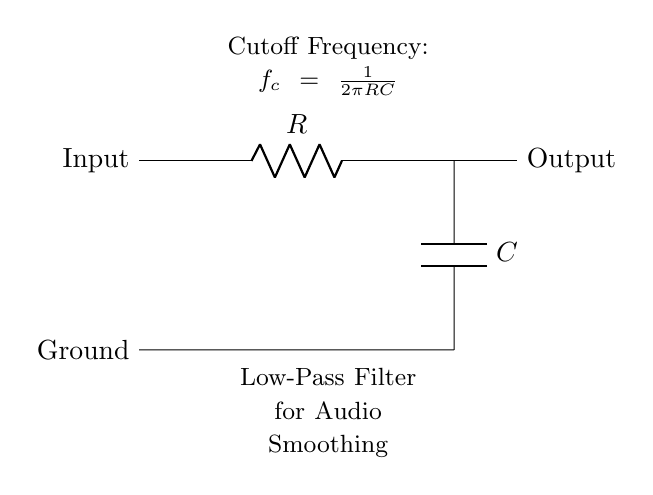What components are used in the circuit? The circuit utilizes a resistor and a capacitor, which are typical components in a low-pass filter. The diagram labels these components as R and C, respectively.
Answer: Resistor and Capacitor What is the function of the low-pass filter? The low-pass filter allows low-frequency signals to pass while attenuating high-frequency signals. This helps in smoothing audio signals, removing noise for better sound quality in animations.
Answer: Smoothing audio signals What is the output of the circuit? The output is taken from the right side of the capacitor, and it represents the smoothed audio signal after filtering.
Answer: Smoothed audio signal What happens to high-frequency signals in this circuit? High-frequency signals are attenuated, meaning their amplitude is reduced significantly, resulting in a cleaner audio output.
Answer: Attenuated How is the cutoff frequency determined? The cutoff frequency is given by the formula f_c = 1/(2πRC). By adjusting R and C values, the designer can set the frequency at which signals start to be filtered out.
Answer: 1/(2πRC) What does the term "ground" refer to in this circuit? Ground serves as a reference point for voltage and is typically at zero volts. It is essential for completing the circuit and ensuring proper operation of the components.
Answer: Zero volts reference 